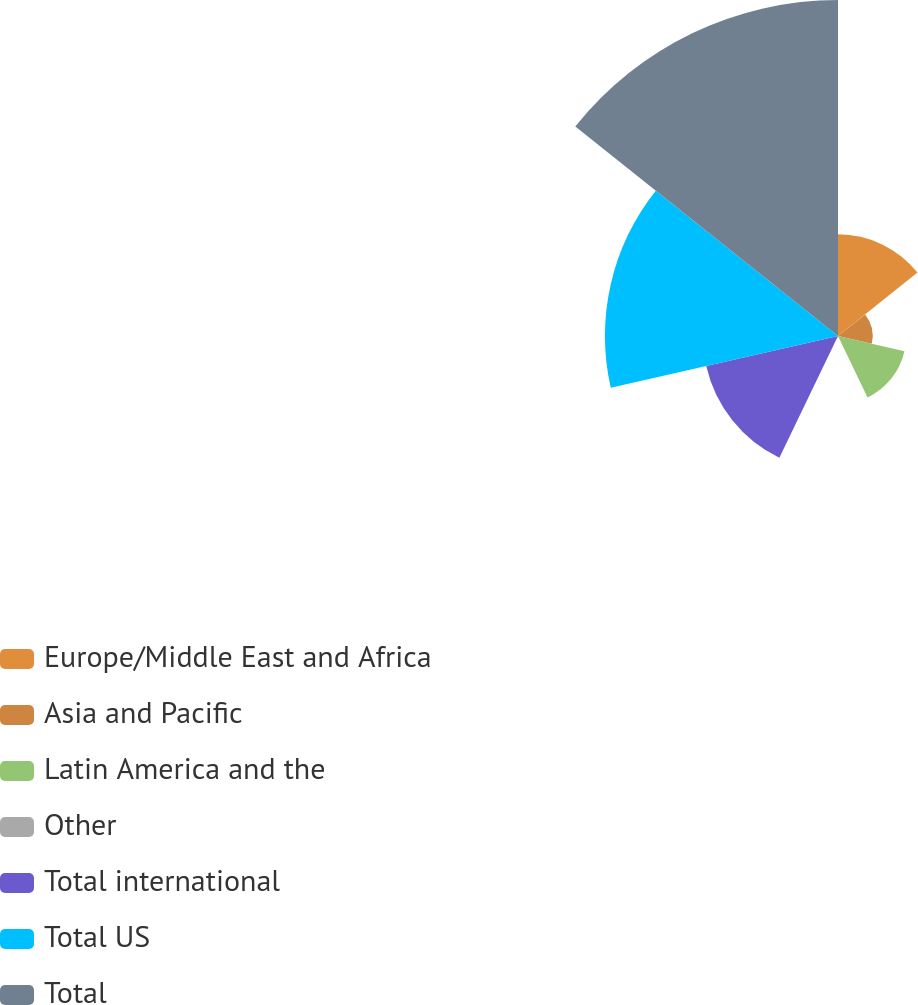<chart> <loc_0><loc_0><loc_500><loc_500><pie_chart><fcel>Europe/Middle East and Africa<fcel>Asia and Pacific<fcel>Latin America and the<fcel>Other<fcel>Total international<fcel>Total US<fcel>Total<nl><fcel>11.17%<fcel>3.81%<fcel>7.49%<fcel>0.14%<fcel>14.85%<fcel>25.61%<fcel>36.92%<nl></chart> 